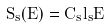Convert formula to latex. <formula><loc_0><loc_0><loc_500><loc_500>S _ { s } ( E ) = C _ { s } l _ { s } E</formula> 